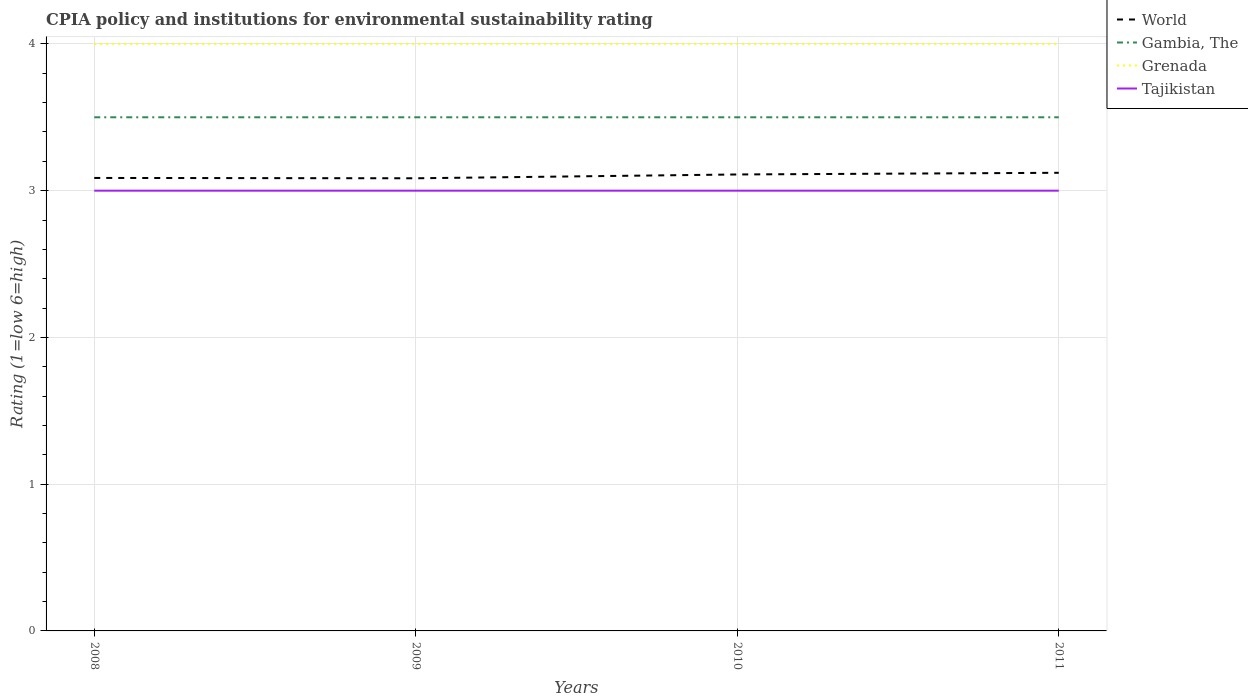What is the total CPIA rating in World in the graph?
Provide a short and direct response. -0.02. What is the difference between the highest and the lowest CPIA rating in Gambia, The?
Provide a succinct answer. 0. Is the CPIA rating in Gambia, The strictly greater than the CPIA rating in World over the years?
Ensure brevity in your answer.  No. How many years are there in the graph?
Ensure brevity in your answer.  4. What is the difference between two consecutive major ticks on the Y-axis?
Your answer should be compact. 1. Does the graph contain grids?
Offer a terse response. Yes. What is the title of the graph?
Provide a short and direct response. CPIA policy and institutions for environmental sustainability rating. Does "Namibia" appear as one of the legend labels in the graph?
Offer a very short reply. No. What is the label or title of the X-axis?
Provide a succinct answer. Years. What is the label or title of the Y-axis?
Your answer should be very brief. Rating (1=low 6=high). What is the Rating (1=low 6=high) of World in 2008?
Offer a very short reply. 3.09. What is the Rating (1=low 6=high) in Gambia, The in 2008?
Provide a succinct answer. 3.5. What is the Rating (1=low 6=high) in World in 2009?
Offer a very short reply. 3.08. What is the Rating (1=low 6=high) of Gambia, The in 2009?
Offer a terse response. 3.5. What is the Rating (1=low 6=high) of World in 2010?
Give a very brief answer. 3.11. What is the Rating (1=low 6=high) in Gambia, The in 2010?
Keep it short and to the point. 3.5. What is the Rating (1=low 6=high) in Tajikistan in 2010?
Give a very brief answer. 3. What is the Rating (1=low 6=high) in World in 2011?
Your response must be concise. 3.12. What is the Rating (1=low 6=high) in Gambia, The in 2011?
Provide a short and direct response. 3.5. Across all years, what is the maximum Rating (1=low 6=high) in World?
Make the answer very short. 3.12. Across all years, what is the maximum Rating (1=low 6=high) in Tajikistan?
Your answer should be very brief. 3. Across all years, what is the minimum Rating (1=low 6=high) of World?
Your answer should be compact. 3.08. Across all years, what is the minimum Rating (1=low 6=high) of Gambia, The?
Your response must be concise. 3.5. Across all years, what is the minimum Rating (1=low 6=high) in Grenada?
Provide a succinct answer. 4. Across all years, what is the minimum Rating (1=low 6=high) of Tajikistan?
Your answer should be very brief. 3. What is the total Rating (1=low 6=high) in World in the graph?
Your answer should be compact. 12.4. What is the total Rating (1=low 6=high) of Tajikistan in the graph?
Make the answer very short. 12. What is the difference between the Rating (1=low 6=high) in World in 2008 and that in 2009?
Your response must be concise. 0. What is the difference between the Rating (1=low 6=high) of Gambia, The in 2008 and that in 2009?
Your answer should be compact. 0. What is the difference between the Rating (1=low 6=high) of Grenada in 2008 and that in 2009?
Your answer should be compact. 0. What is the difference between the Rating (1=low 6=high) of World in 2008 and that in 2010?
Your answer should be compact. -0.02. What is the difference between the Rating (1=low 6=high) of Gambia, The in 2008 and that in 2010?
Give a very brief answer. 0. What is the difference between the Rating (1=low 6=high) in Tajikistan in 2008 and that in 2010?
Offer a very short reply. 0. What is the difference between the Rating (1=low 6=high) in World in 2008 and that in 2011?
Keep it short and to the point. -0.04. What is the difference between the Rating (1=low 6=high) in Gambia, The in 2008 and that in 2011?
Provide a succinct answer. 0. What is the difference between the Rating (1=low 6=high) in Grenada in 2008 and that in 2011?
Ensure brevity in your answer.  0. What is the difference between the Rating (1=low 6=high) of Tajikistan in 2008 and that in 2011?
Keep it short and to the point. 0. What is the difference between the Rating (1=low 6=high) in World in 2009 and that in 2010?
Your answer should be very brief. -0.03. What is the difference between the Rating (1=low 6=high) in Gambia, The in 2009 and that in 2010?
Your response must be concise. 0. What is the difference between the Rating (1=low 6=high) of Grenada in 2009 and that in 2010?
Your answer should be compact. 0. What is the difference between the Rating (1=low 6=high) in World in 2009 and that in 2011?
Your answer should be very brief. -0.04. What is the difference between the Rating (1=low 6=high) in Gambia, The in 2009 and that in 2011?
Make the answer very short. 0. What is the difference between the Rating (1=low 6=high) in Grenada in 2009 and that in 2011?
Your response must be concise. 0. What is the difference between the Rating (1=low 6=high) in Tajikistan in 2009 and that in 2011?
Offer a terse response. 0. What is the difference between the Rating (1=low 6=high) of World in 2010 and that in 2011?
Provide a succinct answer. -0.01. What is the difference between the Rating (1=low 6=high) of Tajikistan in 2010 and that in 2011?
Provide a short and direct response. 0. What is the difference between the Rating (1=low 6=high) of World in 2008 and the Rating (1=low 6=high) of Gambia, The in 2009?
Offer a terse response. -0.41. What is the difference between the Rating (1=low 6=high) in World in 2008 and the Rating (1=low 6=high) in Grenada in 2009?
Your answer should be very brief. -0.91. What is the difference between the Rating (1=low 6=high) of World in 2008 and the Rating (1=low 6=high) of Tajikistan in 2009?
Offer a terse response. 0.09. What is the difference between the Rating (1=low 6=high) of Gambia, The in 2008 and the Rating (1=low 6=high) of Grenada in 2009?
Make the answer very short. -0.5. What is the difference between the Rating (1=low 6=high) of World in 2008 and the Rating (1=low 6=high) of Gambia, The in 2010?
Your answer should be compact. -0.41. What is the difference between the Rating (1=low 6=high) of World in 2008 and the Rating (1=low 6=high) of Grenada in 2010?
Offer a very short reply. -0.91. What is the difference between the Rating (1=low 6=high) of World in 2008 and the Rating (1=low 6=high) of Tajikistan in 2010?
Your response must be concise. 0.09. What is the difference between the Rating (1=low 6=high) in Gambia, The in 2008 and the Rating (1=low 6=high) in Grenada in 2010?
Ensure brevity in your answer.  -0.5. What is the difference between the Rating (1=low 6=high) in Gambia, The in 2008 and the Rating (1=low 6=high) in Tajikistan in 2010?
Ensure brevity in your answer.  0.5. What is the difference between the Rating (1=low 6=high) of Grenada in 2008 and the Rating (1=low 6=high) of Tajikistan in 2010?
Your answer should be compact. 1. What is the difference between the Rating (1=low 6=high) of World in 2008 and the Rating (1=low 6=high) of Gambia, The in 2011?
Your response must be concise. -0.41. What is the difference between the Rating (1=low 6=high) in World in 2008 and the Rating (1=low 6=high) in Grenada in 2011?
Make the answer very short. -0.91. What is the difference between the Rating (1=low 6=high) of World in 2008 and the Rating (1=low 6=high) of Tajikistan in 2011?
Provide a succinct answer. 0.09. What is the difference between the Rating (1=low 6=high) in Gambia, The in 2008 and the Rating (1=low 6=high) in Tajikistan in 2011?
Offer a very short reply. 0.5. What is the difference between the Rating (1=low 6=high) in Grenada in 2008 and the Rating (1=low 6=high) in Tajikistan in 2011?
Ensure brevity in your answer.  1. What is the difference between the Rating (1=low 6=high) in World in 2009 and the Rating (1=low 6=high) in Gambia, The in 2010?
Your response must be concise. -0.42. What is the difference between the Rating (1=low 6=high) of World in 2009 and the Rating (1=low 6=high) of Grenada in 2010?
Give a very brief answer. -0.92. What is the difference between the Rating (1=low 6=high) in World in 2009 and the Rating (1=low 6=high) in Tajikistan in 2010?
Your response must be concise. 0.08. What is the difference between the Rating (1=low 6=high) in Gambia, The in 2009 and the Rating (1=low 6=high) in Grenada in 2010?
Your response must be concise. -0.5. What is the difference between the Rating (1=low 6=high) of Gambia, The in 2009 and the Rating (1=low 6=high) of Tajikistan in 2010?
Ensure brevity in your answer.  0.5. What is the difference between the Rating (1=low 6=high) of Grenada in 2009 and the Rating (1=low 6=high) of Tajikistan in 2010?
Give a very brief answer. 1. What is the difference between the Rating (1=low 6=high) of World in 2009 and the Rating (1=low 6=high) of Gambia, The in 2011?
Offer a very short reply. -0.42. What is the difference between the Rating (1=low 6=high) in World in 2009 and the Rating (1=low 6=high) in Grenada in 2011?
Give a very brief answer. -0.92. What is the difference between the Rating (1=low 6=high) of World in 2009 and the Rating (1=low 6=high) of Tajikistan in 2011?
Your response must be concise. 0.08. What is the difference between the Rating (1=low 6=high) in Gambia, The in 2009 and the Rating (1=low 6=high) in Grenada in 2011?
Offer a very short reply. -0.5. What is the difference between the Rating (1=low 6=high) of World in 2010 and the Rating (1=low 6=high) of Gambia, The in 2011?
Ensure brevity in your answer.  -0.39. What is the difference between the Rating (1=low 6=high) in World in 2010 and the Rating (1=low 6=high) in Grenada in 2011?
Make the answer very short. -0.89. What is the difference between the Rating (1=low 6=high) of World in 2010 and the Rating (1=low 6=high) of Tajikistan in 2011?
Keep it short and to the point. 0.11. What is the difference between the Rating (1=low 6=high) in Grenada in 2010 and the Rating (1=low 6=high) in Tajikistan in 2011?
Keep it short and to the point. 1. What is the average Rating (1=low 6=high) in World per year?
Your answer should be compact. 3.1. What is the average Rating (1=low 6=high) of Gambia, The per year?
Offer a terse response. 3.5. What is the average Rating (1=low 6=high) of Grenada per year?
Your response must be concise. 4. What is the average Rating (1=low 6=high) of Tajikistan per year?
Your answer should be compact. 3. In the year 2008, what is the difference between the Rating (1=low 6=high) of World and Rating (1=low 6=high) of Gambia, The?
Give a very brief answer. -0.41. In the year 2008, what is the difference between the Rating (1=low 6=high) in World and Rating (1=low 6=high) in Grenada?
Keep it short and to the point. -0.91. In the year 2008, what is the difference between the Rating (1=low 6=high) in World and Rating (1=low 6=high) in Tajikistan?
Give a very brief answer. 0.09. In the year 2008, what is the difference between the Rating (1=low 6=high) of Grenada and Rating (1=low 6=high) of Tajikistan?
Offer a terse response. 1. In the year 2009, what is the difference between the Rating (1=low 6=high) of World and Rating (1=low 6=high) of Gambia, The?
Ensure brevity in your answer.  -0.42. In the year 2009, what is the difference between the Rating (1=low 6=high) of World and Rating (1=low 6=high) of Grenada?
Provide a succinct answer. -0.92. In the year 2009, what is the difference between the Rating (1=low 6=high) of World and Rating (1=low 6=high) of Tajikistan?
Keep it short and to the point. 0.08. In the year 2009, what is the difference between the Rating (1=low 6=high) of Gambia, The and Rating (1=low 6=high) of Grenada?
Provide a short and direct response. -0.5. In the year 2009, what is the difference between the Rating (1=low 6=high) of Gambia, The and Rating (1=low 6=high) of Tajikistan?
Make the answer very short. 0.5. In the year 2010, what is the difference between the Rating (1=low 6=high) in World and Rating (1=low 6=high) in Gambia, The?
Your answer should be compact. -0.39. In the year 2010, what is the difference between the Rating (1=low 6=high) of World and Rating (1=low 6=high) of Grenada?
Offer a very short reply. -0.89. In the year 2010, what is the difference between the Rating (1=low 6=high) in World and Rating (1=low 6=high) in Tajikistan?
Provide a short and direct response. 0.11. In the year 2010, what is the difference between the Rating (1=low 6=high) of Gambia, The and Rating (1=low 6=high) of Grenada?
Make the answer very short. -0.5. In the year 2010, what is the difference between the Rating (1=low 6=high) in Grenada and Rating (1=low 6=high) in Tajikistan?
Provide a short and direct response. 1. In the year 2011, what is the difference between the Rating (1=low 6=high) in World and Rating (1=low 6=high) in Gambia, The?
Provide a succinct answer. -0.38. In the year 2011, what is the difference between the Rating (1=low 6=high) in World and Rating (1=low 6=high) in Grenada?
Provide a short and direct response. -0.88. In the year 2011, what is the difference between the Rating (1=low 6=high) in World and Rating (1=low 6=high) in Tajikistan?
Your answer should be very brief. 0.12. In the year 2011, what is the difference between the Rating (1=low 6=high) of Grenada and Rating (1=low 6=high) of Tajikistan?
Offer a very short reply. 1. What is the ratio of the Rating (1=low 6=high) in Tajikistan in 2008 to that in 2009?
Offer a terse response. 1. What is the ratio of the Rating (1=low 6=high) of Gambia, The in 2008 to that in 2010?
Your answer should be very brief. 1. What is the ratio of the Rating (1=low 6=high) of Tajikistan in 2008 to that in 2010?
Your response must be concise. 1. What is the ratio of the Rating (1=low 6=high) of World in 2008 to that in 2011?
Your answer should be very brief. 0.99. What is the ratio of the Rating (1=low 6=high) of Tajikistan in 2008 to that in 2011?
Make the answer very short. 1. What is the ratio of the Rating (1=low 6=high) in Gambia, The in 2009 to that in 2010?
Make the answer very short. 1. What is the ratio of the Rating (1=low 6=high) in Gambia, The in 2009 to that in 2011?
Give a very brief answer. 1. What is the ratio of the Rating (1=low 6=high) of Grenada in 2009 to that in 2011?
Make the answer very short. 1. What is the ratio of the Rating (1=low 6=high) in Gambia, The in 2010 to that in 2011?
Give a very brief answer. 1. What is the ratio of the Rating (1=low 6=high) in Grenada in 2010 to that in 2011?
Offer a very short reply. 1. What is the ratio of the Rating (1=low 6=high) of Tajikistan in 2010 to that in 2011?
Provide a short and direct response. 1. What is the difference between the highest and the second highest Rating (1=low 6=high) of World?
Offer a very short reply. 0.01. What is the difference between the highest and the second highest Rating (1=low 6=high) of Gambia, The?
Offer a terse response. 0. What is the difference between the highest and the second highest Rating (1=low 6=high) of Grenada?
Your response must be concise. 0. What is the difference between the highest and the second highest Rating (1=low 6=high) of Tajikistan?
Give a very brief answer. 0. What is the difference between the highest and the lowest Rating (1=low 6=high) in World?
Give a very brief answer. 0.04. What is the difference between the highest and the lowest Rating (1=low 6=high) in Grenada?
Keep it short and to the point. 0. 